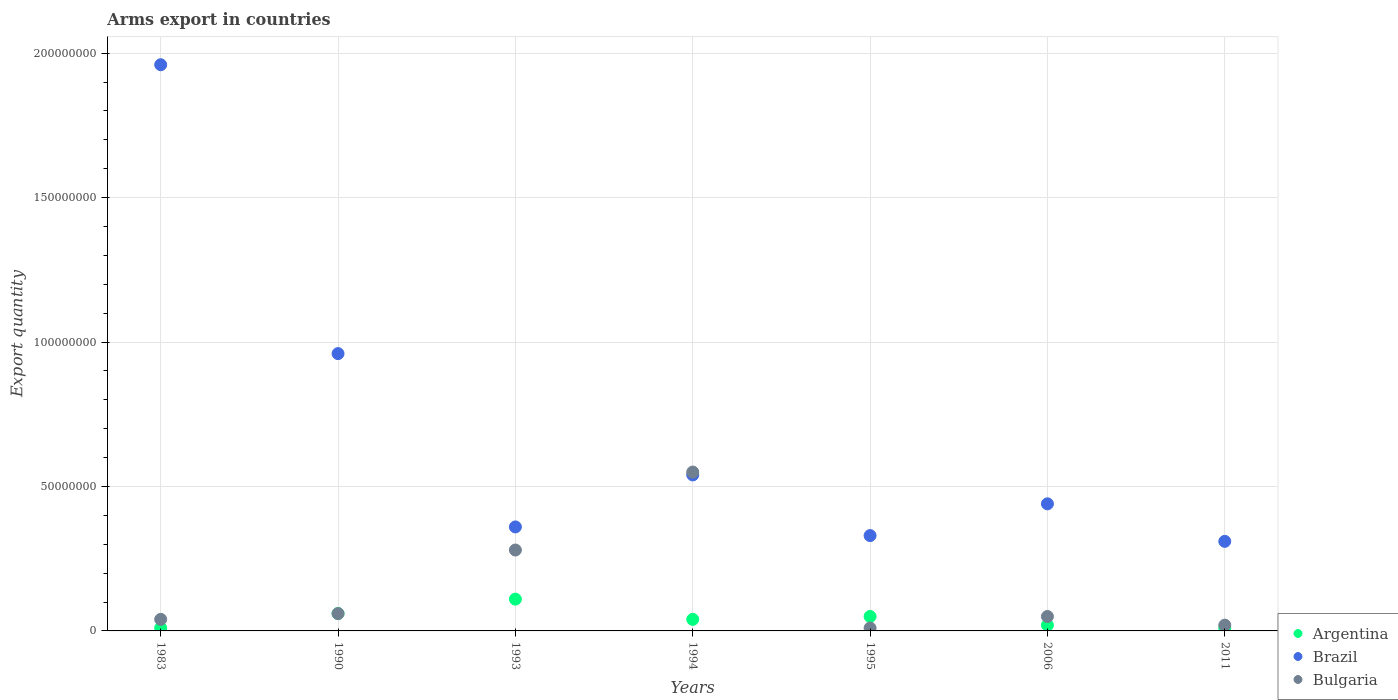Is the number of dotlines equal to the number of legend labels?
Make the answer very short. Yes. What is the total arms export in Bulgaria in 1990?
Make the answer very short. 6.00e+06. Across all years, what is the maximum total arms export in Brazil?
Your answer should be compact. 1.96e+08. Across all years, what is the minimum total arms export in Brazil?
Keep it short and to the point. 3.10e+07. What is the total total arms export in Argentina in the graph?
Provide a succinct answer. 3.00e+07. What is the difference between the total arms export in Brazil in 1983 and that in 1994?
Your response must be concise. 1.42e+08. What is the difference between the total arms export in Bulgaria in 1994 and the total arms export in Brazil in 1995?
Offer a terse response. 2.20e+07. What is the average total arms export in Brazil per year?
Keep it short and to the point. 7.00e+07. In the year 1990, what is the difference between the total arms export in Bulgaria and total arms export in Argentina?
Provide a short and direct response. 0. In how many years, is the total arms export in Brazil greater than 180000000?
Offer a very short reply. 1. What is the ratio of the total arms export in Brazil in 1990 to that in 2011?
Give a very brief answer. 3.1. Is the total arms export in Argentina in 1993 less than that in 2006?
Your answer should be very brief. No. Is the difference between the total arms export in Bulgaria in 1983 and 1995 greater than the difference between the total arms export in Argentina in 1983 and 1995?
Provide a short and direct response. Yes. What is the difference between the highest and the second highest total arms export in Bulgaria?
Your answer should be very brief. 2.70e+07. In how many years, is the total arms export in Argentina greater than the average total arms export in Argentina taken over all years?
Offer a very short reply. 3. Is the sum of the total arms export in Brazil in 1990 and 2006 greater than the maximum total arms export in Bulgaria across all years?
Provide a succinct answer. Yes. Is it the case that in every year, the sum of the total arms export in Brazil and total arms export in Argentina  is greater than the total arms export in Bulgaria?
Give a very brief answer. Yes. Does the total arms export in Brazil monotonically increase over the years?
Keep it short and to the point. No. Is the total arms export in Brazil strictly greater than the total arms export in Argentina over the years?
Provide a short and direct response. Yes. Are the values on the major ticks of Y-axis written in scientific E-notation?
Offer a terse response. No. What is the title of the graph?
Keep it short and to the point. Arms export in countries. What is the label or title of the X-axis?
Offer a terse response. Years. What is the label or title of the Y-axis?
Offer a terse response. Export quantity. What is the Export quantity in Argentina in 1983?
Your response must be concise. 1.00e+06. What is the Export quantity of Brazil in 1983?
Offer a very short reply. 1.96e+08. What is the Export quantity in Bulgaria in 1983?
Your answer should be very brief. 4.00e+06. What is the Export quantity in Brazil in 1990?
Provide a short and direct response. 9.60e+07. What is the Export quantity of Bulgaria in 1990?
Offer a terse response. 6.00e+06. What is the Export quantity in Argentina in 1993?
Offer a terse response. 1.10e+07. What is the Export quantity in Brazil in 1993?
Your response must be concise. 3.60e+07. What is the Export quantity in Bulgaria in 1993?
Your response must be concise. 2.80e+07. What is the Export quantity in Argentina in 1994?
Offer a very short reply. 4.00e+06. What is the Export quantity of Brazil in 1994?
Offer a terse response. 5.40e+07. What is the Export quantity of Bulgaria in 1994?
Offer a very short reply. 5.50e+07. What is the Export quantity of Brazil in 1995?
Your answer should be compact. 3.30e+07. What is the Export quantity in Brazil in 2006?
Offer a very short reply. 4.40e+07. What is the Export quantity in Brazil in 2011?
Offer a very short reply. 3.10e+07. Across all years, what is the maximum Export quantity of Argentina?
Offer a terse response. 1.10e+07. Across all years, what is the maximum Export quantity in Brazil?
Provide a short and direct response. 1.96e+08. Across all years, what is the maximum Export quantity in Bulgaria?
Offer a very short reply. 5.50e+07. Across all years, what is the minimum Export quantity of Argentina?
Provide a short and direct response. 1.00e+06. Across all years, what is the minimum Export quantity in Brazil?
Offer a very short reply. 3.10e+07. What is the total Export quantity of Argentina in the graph?
Provide a succinct answer. 3.00e+07. What is the total Export quantity of Brazil in the graph?
Give a very brief answer. 4.90e+08. What is the total Export quantity in Bulgaria in the graph?
Your response must be concise. 1.01e+08. What is the difference between the Export quantity in Argentina in 1983 and that in 1990?
Provide a short and direct response. -5.00e+06. What is the difference between the Export quantity of Brazil in 1983 and that in 1990?
Ensure brevity in your answer.  1.00e+08. What is the difference between the Export quantity of Bulgaria in 1983 and that in 1990?
Give a very brief answer. -2.00e+06. What is the difference between the Export quantity of Argentina in 1983 and that in 1993?
Your response must be concise. -1.00e+07. What is the difference between the Export quantity in Brazil in 1983 and that in 1993?
Ensure brevity in your answer.  1.60e+08. What is the difference between the Export quantity in Bulgaria in 1983 and that in 1993?
Provide a short and direct response. -2.40e+07. What is the difference between the Export quantity in Brazil in 1983 and that in 1994?
Provide a short and direct response. 1.42e+08. What is the difference between the Export quantity of Bulgaria in 1983 and that in 1994?
Give a very brief answer. -5.10e+07. What is the difference between the Export quantity in Brazil in 1983 and that in 1995?
Offer a very short reply. 1.63e+08. What is the difference between the Export quantity of Bulgaria in 1983 and that in 1995?
Offer a terse response. 3.00e+06. What is the difference between the Export quantity of Argentina in 1983 and that in 2006?
Your answer should be compact. -1.00e+06. What is the difference between the Export quantity of Brazil in 1983 and that in 2006?
Offer a very short reply. 1.52e+08. What is the difference between the Export quantity of Bulgaria in 1983 and that in 2006?
Offer a very short reply. -1.00e+06. What is the difference between the Export quantity in Argentina in 1983 and that in 2011?
Keep it short and to the point. 0. What is the difference between the Export quantity of Brazil in 1983 and that in 2011?
Keep it short and to the point. 1.65e+08. What is the difference between the Export quantity of Bulgaria in 1983 and that in 2011?
Offer a very short reply. 2.00e+06. What is the difference between the Export quantity of Argentina in 1990 and that in 1993?
Offer a terse response. -5.00e+06. What is the difference between the Export quantity of Brazil in 1990 and that in 1993?
Your answer should be compact. 6.00e+07. What is the difference between the Export quantity in Bulgaria in 1990 and that in 1993?
Ensure brevity in your answer.  -2.20e+07. What is the difference between the Export quantity of Argentina in 1990 and that in 1994?
Keep it short and to the point. 2.00e+06. What is the difference between the Export quantity of Brazil in 1990 and that in 1994?
Keep it short and to the point. 4.20e+07. What is the difference between the Export quantity in Bulgaria in 1990 and that in 1994?
Ensure brevity in your answer.  -4.90e+07. What is the difference between the Export quantity of Argentina in 1990 and that in 1995?
Give a very brief answer. 1.00e+06. What is the difference between the Export quantity in Brazil in 1990 and that in 1995?
Provide a short and direct response. 6.30e+07. What is the difference between the Export quantity of Bulgaria in 1990 and that in 1995?
Give a very brief answer. 5.00e+06. What is the difference between the Export quantity of Argentina in 1990 and that in 2006?
Keep it short and to the point. 4.00e+06. What is the difference between the Export quantity in Brazil in 1990 and that in 2006?
Offer a very short reply. 5.20e+07. What is the difference between the Export quantity in Bulgaria in 1990 and that in 2006?
Ensure brevity in your answer.  1.00e+06. What is the difference between the Export quantity of Argentina in 1990 and that in 2011?
Provide a succinct answer. 5.00e+06. What is the difference between the Export quantity of Brazil in 1990 and that in 2011?
Ensure brevity in your answer.  6.50e+07. What is the difference between the Export quantity in Brazil in 1993 and that in 1994?
Provide a short and direct response. -1.80e+07. What is the difference between the Export quantity of Bulgaria in 1993 and that in 1994?
Offer a terse response. -2.70e+07. What is the difference between the Export quantity of Argentina in 1993 and that in 1995?
Offer a terse response. 6.00e+06. What is the difference between the Export quantity in Bulgaria in 1993 and that in 1995?
Give a very brief answer. 2.70e+07. What is the difference between the Export quantity of Argentina in 1993 and that in 2006?
Give a very brief answer. 9.00e+06. What is the difference between the Export quantity in Brazil in 1993 and that in 2006?
Your answer should be compact. -8.00e+06. What is the difference between the Export quantity in Bulgaria in 1993 and that in 2006?
Offer a terse response. 2.30e+07. What is the difference between the Export quantity of Argentina in 1993 and that in 2011?
Keep it short and to the point. 1.00e+07. What is the difference between the Export quantity in Brazil in 1993 and that in 2011?
Your answer should be very brief. 5.00e+06. What is the difference between the Export quantity in Bulgaria in 1993 and that in 2011?
Offer a very short reply. 2.60e+07. What is the difference between the Export quantity of Brazil in 1994 and that in 1995?
Your response must be concise. 2.10e+07. What is the difference between the Export quantity in Bulgaria in 1994 and that in 1995?
Keep it short and to the point. 5.40e+07. What is the difference between the Export quantity in Argentina in 1994 and that in 2006?
Your answer should be compact. 2.00e+06. What is the difference between the Export quantity of Brazil in 1994 and that in 2006?
Provide a succinct answer. 1.00e+07. What is the difference between the Export quantity of Bulgaria in 1994 and that in 2006?
Provide a short and direct response. 5.00e+07. What is the difference between the Export quantity of Brazil in 1994 and that in 2011?
Your response must be concise. 2.30e+07. What is the difference between the Export quantity in Bulgaria in 1994 and that in 2011?
Your answer should be compact. 5.30e+07. What is the difference between the Export quantity of Argentina in 1995 and that in 2006?
Your answer should be compact. 3.00e+06. What is the difference between the Export quantity of Brazil in 1995 and that in 2006?
Keep it short and to the point. -1.10e+07. What is the difference between the Export quantity of Bulgaria in 1995 and that in 2006?
Provide a short and direct response. -4.00e+06. What is the difference between the Export quantity in Argentina in 1995 and that in 2011?
Provide a short and direct response. 4.00e+06. What is the difference between the Export quantity of Argentina in 2006 and that in 2011?
Ensure brevity in your answer.  1.00e+06. What is the difference between the Export quantity of Brazil in 2006 and that in 2011?
Your answer should be compact. 1.30e+07. What is the difference between the Export quantity of Argentina in 1983 and the Export quantity of Brazil in 1990?
Make the answer very short. -9.50e+07. What is the difference between the Export quantity in Argentina in 1983 and the Export quantity in Bulgaria in 1990?
Make the answer very short. -5.00e+06. What is the difference between the Export quantity in Brazil in 1983 and the Export quantity in Bulgaria in 1990?
Ensure brevity in your answer.  1.90e+08. What is the difference between the Export quantity in Argentina in 1983 and the Export quantity in Brazil in 1993?
Offer a very short reply. -3.50e+07. What is the difference between the Export quantity of Argentina in 1983 and the Export quantity of Bulgaria in 1993?
Give a very brief answer. -2.70e+07. What is the difference between the Export quantity in Brazil in 1983 and the Export quantity in Bulgaria in 1993?
Give a very brief answer. 1.68e+08. What is the difference between the Export quantity of Argentina in 1983 and the Export quantity of Brazil in 1994?
Ensure brevity in your answer.  -5.30e+07. What is the difference between the Export quantity of Argentina in 1983 and the Export quantity of Bulgaria in 1994?
Keep it short and to the point. -5.40e+07. What is the difference between the Export quantity of Brazil in 1983 and the Export quantity of Bulgaria in 1994?
Give a very brief answer. 1.41e+08. What is the difference between the Export quantity in Argentina in 1983 and the Export quantity in Brazil in 1995?
Offer a terse response. -3.20e+07. What is the difference between the Export quantity in Brazil in 1983 and the Export quantity in Bulgaria in 1995?
Keep it short and to the point. 1.95e+08. What is the difference between the Export quantity of Argentina in 1983 and the Export quantity of Brazil in 2006?
Provide a succinct answer. -4.30e+07. What is the difference between the Export quantity in Argentina in 1983 and the Export quantity in Bulgaria in 2006?
Make the answer very short. -4.00e+06. What is the difference between the Export quantity in Brazil in 1983 and the Export quantity in Bulgaria in 2006?
Provide a short and direct response. 1.91e+08. What is the difference between the Export quantity of Argentina in 1983 and the Export quantity of Brazil in 2011?
Ensure brevity in your answer.  -3.00e+07. What is the difference between the Export quantity in Argentina in 1983 and the Export quantity in Bulgaria in 2011?
Keep it short and to the point. -1.00e+06. What is the difference between the Export quantity in Brazil in 1983 and the Export quantity in Bulgaria in 2011?
Provide a short and direct response. 1.94e+08. What is the difference between the Export quantity in Argentina in 1990 and the Export quantity in Brazil in 1993?
Your response must be concise. -3.00e+07. What is the difference between the Export quantity of Argentina in 1990 and the Export quantity of Bulgaria in 1993?
Your answer should be compact. -2.20e+07. What is the difference between the Export quantity in Brazil in 1990 and the Export quantity in Bulgaria in 1993?
Ensure brevity in your answer.  6.80e+07. What is the difference between the Export quantity of Argentina in 1990 and the Export quantity of Brazil in 1994?
Keep it short and to the point. -4.80e+07. What is the difference between the Export quantity in Argentina in 1990 and the Export quantity in Bulgaria in 1994?
Offer a terse response. -4.90e+07. What is the difference between the Export quantity in Brazil in 1990 and the Export quantity in Bulgaria in 1994?
Offer a terse response. 4.10e+07. What is the difference between the Export quantity in Argentina in 1990 and the Export quantity in Brazil in 1995?
Make the answer very short. -2.70e+07. What is the difference between the Export quantity of Argentina in 1990 and the Export quantity of Bulgaria in 1995?
Make the answer very short. 5.00e+06. What is the difference between the Export quantity of Brazil in 1990 and the Export quantity of Bulgaria in 1995?
Your answer should be very brief. 9.50e+07. What is the difference between the Export quantity in Argentina in 1990 and the Export quantity in Brazil in 2006?
Your answer should be compact. -3.80e+07. What is the difference between the Export quantity in Argentina in 1990 and the Export quantity in Bulgaria in 2006?
Provide a succinct answer. 1.00e+06. What is the difference between the Export quantity in Brazil in 1990 and the Export quantity in Bulgaria in 2006?
Your response must be concise. 9.10e+07. What is the difference between the Export quantity of Argentina in 1990 and the Export quantity of Brazil in 2011?
Your answer should be compact. -2.50e+07. What is the difference between the Export quantity in Brazil in 1990 and the Export quantity in Bulgaria in 2011?
Give a very brief answer. 9.40e+07. What is the difference between the Export quantity of Argentina in 1993 and the Export quantity of Brazil in 1994?
Your answer should be compact. -4.30e+07. What is the difference between the Export quantity in Argentina in 1993 and the Export quantity in Bulgaria in 1994?
Provide a short and direct response. -4.40e+07. What is the difference between the Export quantity of Brazil in 1993 and the Export quantity of Bulgaria in 1994?
Keep it short and to the point. -1.90e+07. What is the difference between the Export quantity in Argentina in 1993 and the Export quantity in Brazil in 1995?
Your response must be concise. -2.20e+07. What is the difference between the Export quantity in Argentina in 1993 and the Export quantity in Bulgaria in 1995?
Your answer should be very brief. 1.00e+07. What is the difference between the Export quantity in Brazil in 1993 and the Export quantity in Bulgaria in 1995?
Offer a very short reply. 3.50e+07. What is the difference between the Export quantity in Argentina in 1993 and the Export quantity in Brazil in 2006?
Your response must be concise. -3.30e+07. What is the difference between the Export quantity of Brazil in 1993 and the Export quantity of Bulgaria in 2006?
Make the answer very short. 3.10e+07. What is the difference between the Export quantity of Argentina in 1993 and the Export quantity of Brazil in 2011?
Your answer should be compact. -2.00e+07. What is the difference between the Export quantity of Argentina in 1993 and the Export quantity of Bulgaria in 2011?
Provide a short and direct response. 9.00e+06. What is the difference between the Export quantity in Brazil in 1993 and the Export quantity in Bulgaria in 2011?
Offer a terse response. 3.40e+07. What is the difference between the Export quantity in Argentina in 1994 and the Export quantity in Brazil in 1995?
Your response must be concise. -2.90e+07. What is the difference between the Export quantity in Argentina in 1994 and the Export quantity in Bulgaria in 1995?
Make the answer very short. 3.00e+06. What is the difference between the Export quantity in Brazil in 1994 and the Export quantity in Bulgaria in 1995?
Your answer should be very brief. 5.30e+07. What is the difference between the Export quantity in Argentina in 1994 and the Export quantity in Brazil in 2006?
Ensure brevity in your answer.  -4.00e+07. What is the difference between the Export quantity in Argentina in 1994 and the Export quantity in Bulgaria in 2006?
Ensure brevity in your answer.  -1.00e+06. What is the difference between the Export quantity of Brazil in 1994 and the Export quantity of Bulgaria in 2006?
Provide a short and direct response. 4.90e+07. What is the difference between the Export quantity of Argentina in 1994 and the Export quantity of Brazil in 2011?
Ensure brevity in your answer.  -2.70e+07. What is the difference between the Export quantity in Brazil in 1994 and the Export quantity in Bulgaria in 2011?
Your answer should be very brief. 5.20e+07. What is the difference between the Export quantity of Argentina in 1995 and the Export quantity of Brazil in 2006?
Provide a succinct answer. -3.90e+07. What is the difference between the Export quantity of Argentina in 1995 and the Export quantity of Bulgaria in 2006?
Make the answer very short. 0. What is the difference between the Export quantity of Brazil in 1995 and the Export quantity of Bulgaria in 2006?
Provide a succinct answer. 2.80e+07. What is the difference between the Export quantity in Argentina in 1995 and the Export quantity in Brazil in 2011?
Your answer should be very brief. -2.60e+07. What is the difference between the Export quantity of Argentina in 1995 and the Export quantity of Bulgaria in 2011?
Provide a succinct answer. 3.00e+06. What is the difference between the Export quantity in Brazil in 1995 and the Export quantity in Bulgaria in 2011?
Your answer should be compact. 3.10e+07. What is the difference between the Export quantity of Argentina in 2006 and the Export quantity of Brazil in 2011?
Ensure brevity in your answer.  -2.90e+07. What is the difference between the Export quantity of Brazil in 2006 and the Export quantity of Bulgaria in 2011?
Offer a terse response. 4.20e+07. What is the average Export quantity in Argentina per year?
Your response must be concise. 4.29e+06. What is the average Export quantity in Brazil per year?
Your response must be concise. 7.00e+07. What is the average Export quantity of Bulgaria per year?
Offer a terse response. 1.44e+07. In the year 1983, what is the difference between the Export quantity in Argentina and Export quantity in Brazil?
Make the answer very short. -1.95e+08. In the year 1983, what is the difference between the Export quantity in Argentina and Export quantity in Bulgaria?
Ensure brevity in your answer.  -3.00e+06. In the year 1983, what is the difference between the Export quantity in Brazil and Export quantity in Bulgaria?
Offer a terse response. 1.92e+08. In the year 1990, what is the difference between the Export quantity in Argentina and Export quantity in Brazil?
Ensure brevity in your answer.  -9.00e+07. In the year 1990, what is the difference between the Export quantity in Argentina and Export quantity in Bulgaria?
Offer a terse response. 0. In the year 1990, what is the difference between the Export quantity of Brazil and Export quantity of Bulgaria?
Keep it short and to the point. 9.00e+07. In the year 1993, what is the difference between the Export quantity in Argentina and Export quantity in Brazil?
Offer a terse response. -2.50e+07. In the year 1993, what is the difference between the Export quantity of Argentina and Export quantity of Bulgaria?
Your answer should be compact. -1.70e+07. In the year 1993, what is the difference between the Export quantity of Brazil and Export quantity of Bulgaria?
Ensure brevity in your answer.  8.00e+06. In the year 1994, what is the difference between the Export quantity of Argentina and Export quantity of Brazil?
Provide a succinct answer. -5.00e+07. In the year 1994, what is the difference between the Export quantity in Argentina and Export quantity in Bulgaria?
Give a very brief answer. -5.10e+07. In the year 1995, what is the difference between the Export quantity in Argentina and Export quantity in Brazil?
Offer a very short reply. -2.80e+07. In the year 1995, what is the difference between the Export quantity in Brazil and Export quantity in Bulgaria?
Give a very brief answer. 3.20e+07. In the year 2006, what is the difference between the Export quantity in Argentina and Export quantity in Brazil?
Give a very brief answer. -4.20e+07. In the year 2006, what is the difference between the Export quantity of Argentina and Export quantity of Bulgaria?
Provide a succinct answer. -3.00e+06. In the year 2006, what is the difference between the Export quantity of Brazil and Export quantity of Bulgaria?
Keep it short and to the point. 3.90e+07. In the year 2011, what is the difference between the Export quantity of Argentina and Export quantity of Brazil?
Your answer should be very brief. -3.00e+07. In the year 2011, what is the difference between the Export quantity in Argentina and Export quantity in Bulgaria?
Offer a terse response. -1.00e+06. In the year 2011, what is the difference between the Export quantity in Brazil and Export quantity in Bulgaria?
Offer a terse response. 2.90e+07. What is the ratio of the Export quantity of Brazil in 1983 to that in 1990?
Give a very brief answer. 2.04. What is the ratio of the Export quantity of Bulgaria in 1983 to that in 1990?
Offer a very short reply. 0.67. What is the ratio of the Export quantity of Argentina in 1983 to that in 1993?
Your response must be concise. 0.09. What is the ratio of the Export quantity of Brazil in 1983 to that in 1993?
Your answer should be very brief. 5.44. What is the ratio of the Export quantity in Bulgaria in 1983 to that in 1993?
Offer a terse response. 0.14. What is the ratio of the Export quantity in Brazil in 1983 to that in 1994?
Make the answer very short. 3.63. What is the ratio of the Export quantity of Bulgaria in 1983 to that in 1994?
Keep it short and to the point. 0.07. What is the ratio of the Export quantity in Argentina in 1983 to that in 1995?
Give a very brief answer. 0.2. What is the ratio of the Export quantity of Brazil in 1983 to that in 1995?
Keep it short and to the point. 5.94. What is the ratio of the Export quantity of Argentina in 1983 to that in 2006?
Offer a terse response. 0.5. What is the ratio of the Export quantity of Brazil in 1983 to that in 2006?
Your answer should be very brief. 4.45. What is the ratio of the Export quantity of Bulgaria in 1983 to that in 2006?
Keep it short and to the point. 0.8. What is the ratio of the Export quantity in Brazil in 1983 to that in 2011?
Provide a succinct answer. 6.32. What is the ratio of the Export quantity of Bulgaria in 1983 to that in 2011?
Provide a succinct answer. 2. What is the ratio of the Export quantity of Argentina in 1990 to that in 1993?
Your answer should be compact. 0.55. What is the ratio of the Export quantity in Brazil in 1990 to that in 1993?
Your response must be concise. 2.67. What is the ratio of the Export quantity of Bulgaria in 1990 to that in 1993?
Provide a succinct answer. 0.21. What is the ratio of the Export quantity in Argentina in 1990 to that in 1994?
Give a very brief answer. 1.5. What is the ratio of the Export quantity in Brazil in 1990 to that in 1994?
Provide a succinct answer. 1.78. What is the ratio of the Export quantity of Bulgaria in 1990 to that in 1994?
Offer a very short reply. 0.11. What is the ratio of the Export quantity of Argentina in 1990 to that in 1995?
Keep it short and to the point. 1.2. What is the ratio of the Export quantity in Brazil in 1990 to that in 1995?
Give a very brief answer. 2.91. What is the ratio of the Export quantity in Bulgaria in 1990 to that in 1995?
Your response must be concise. 6. What is the ratio of the Export quantity in Brazil in 1990 to that in 2006?
Ensure brevity in your answer.  2.18. What is the ratio of the Export quantity of Bulgaria in 1990 to that in 2006?
Offer a very short reply. 1.2. What is the ratio of the Export quantity of Brazil in 1990 to that in 2011?
Your answer should be compact. 3.1. What is the ratio of the Export quantity in Bulgaria in 1990 to that in 2011?
Offer a terse response. 3. What is the ratio of the Export quantity in Argentina in 1993 to that in 1994?
Make the answer very short. 2.75. What is the ratio of the Export quantity in Brazil in 1993 to that in 1994?
Offer a very short reply. 0.67. What is the ratio of the Export quantity in Bulgaria in 1993 to that in 1994?
Your response must be concise. 0.51. What is the ratio of the Export quantity in Bulgaria in 1993 to that in 1995?
Give a very brief answer. 28. What is the ratio of the Export quantity of Argentina in 1993 to that in 2006?
Give a very brief answer. 5.5. What is the ratio of the Export quantity of Brazil in 1993 to that in 2006?
Give a very brief answer. 0.82. What is the ratio of the Export quantity in Bulgaria in 1993 to that in 2006?
Provide a short and direct response. 5.6. What is the ratio of the Export quantity in Brazil in 1993 to that in 2011?
Your answer should be very brief. 1.16. What is the ratio of the Export quantity of Bulgaria in 1993 to that in 2011?
Make the answer very short. 14. What is the ratio of the Export quantity of Argentina in 1994 to that in 1995?
Your answer should be compact. 0.8. What is the ratio of the Export quantity of Brazil in 1994 to that in 1995?
Your answer should be compact. 1.64. What is the ratio of the Export quantity in Bulgaria in 1994 to that in 1995?
Make the answer very short. 55. What is the ratio of the Export quantity in Argentina in 1994 to that in 2006?
Offer a very short reply. 2. What is the ratio of the Export quantity in Brazil in 1994 to that in 2006?
Make the answer very short. 1.23. What is the ratio of the Export quantity of Bulgaria in 1994 to that in 2006?
Provide a succinct answer. 11. What is the ratio of the Export quantity of Argentina in 1994 to that in 2011?
Make the answer very short. 4. What is the ratio of the Export quantity of Brazil in 1994 to that in 2011?
Provide a short and direct response. 1.74. What is the ratio of the Export quantity in Argentina in 1995 to that in 2006?
Offer a terse response. 2.5. What is the ratio of the Export quantity in Brazil in 1995 to that in 2006?
Provide a short and direct response. 0.75. What is the ratio of the Export quantity in Bulgaria in 1995 to that in 2006?
Your response must be concise. 0.2. What is the ratio of the Export quantity of Argentina in 1995 to that in 2011?
Your answer should be compact. 5. What is the ratio of the Export quantity of Brazil in 1995 to that in 2011?
Your response must be concise. 1.06. What is the ratio of the Export quantity of Bulgaria in 1995 to that in 2011?
Give a very brief answer. 0.5. What is the ratio of the Export quantity in Brazil in 2006 to that in 2011?
Ensure brevity in your answer.  1.42. What is the difference between the highest and the second highest Export quantity in Argentina?
Keep it short and to the point. 5.00e+06. What is the difference between the highest and the second highest Export quantity of Bulgaria?
Your answer should be very brief. 2.70e+07. What is the difference between the highest and the lowest Export quantity in Brazil?
Provide a short and direct response. 1.65e+08. What is the difference between the highest and the lowest Export quantity of Bulgaria?
Offer a very short reply. 5.40e+07. 